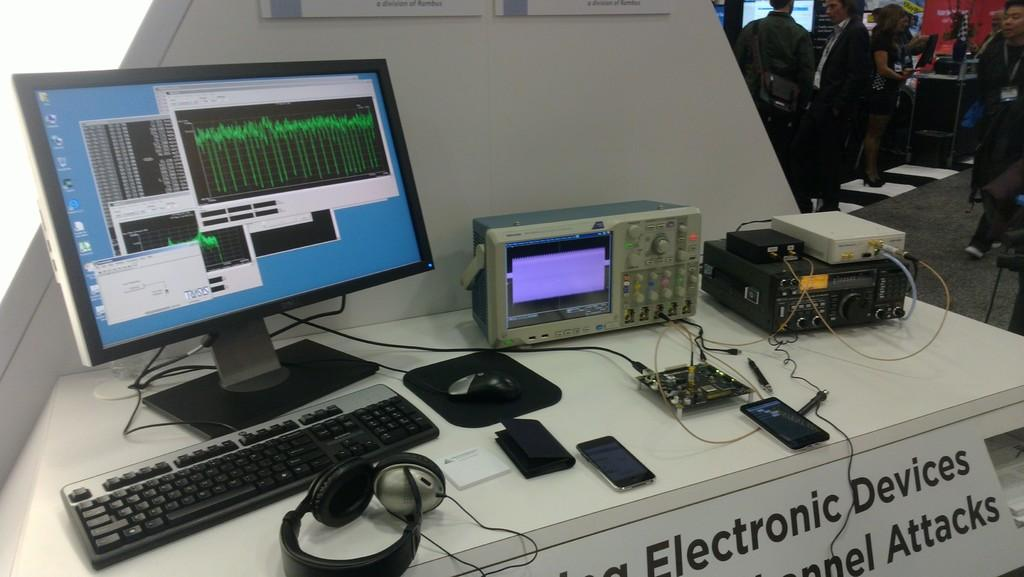<image>
Relay a brief, clear account of the picture shown. a computer system is displayed above a sign that reads elecontric devices 